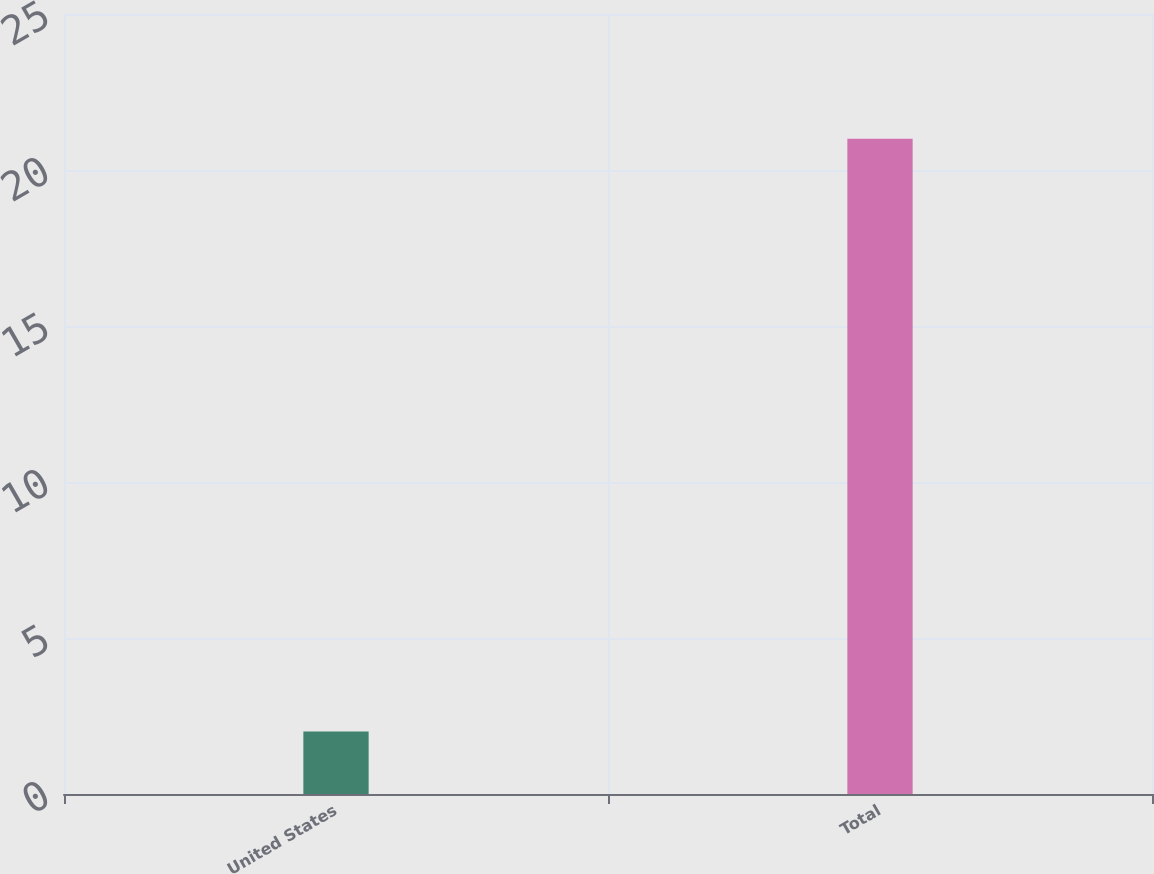<chart> <loc_0><loc_0><loc_500><loc_500><bar_chart><fcel>United States<fcel>Total<nl><fcel>2<fcel>21<nl></chart> 